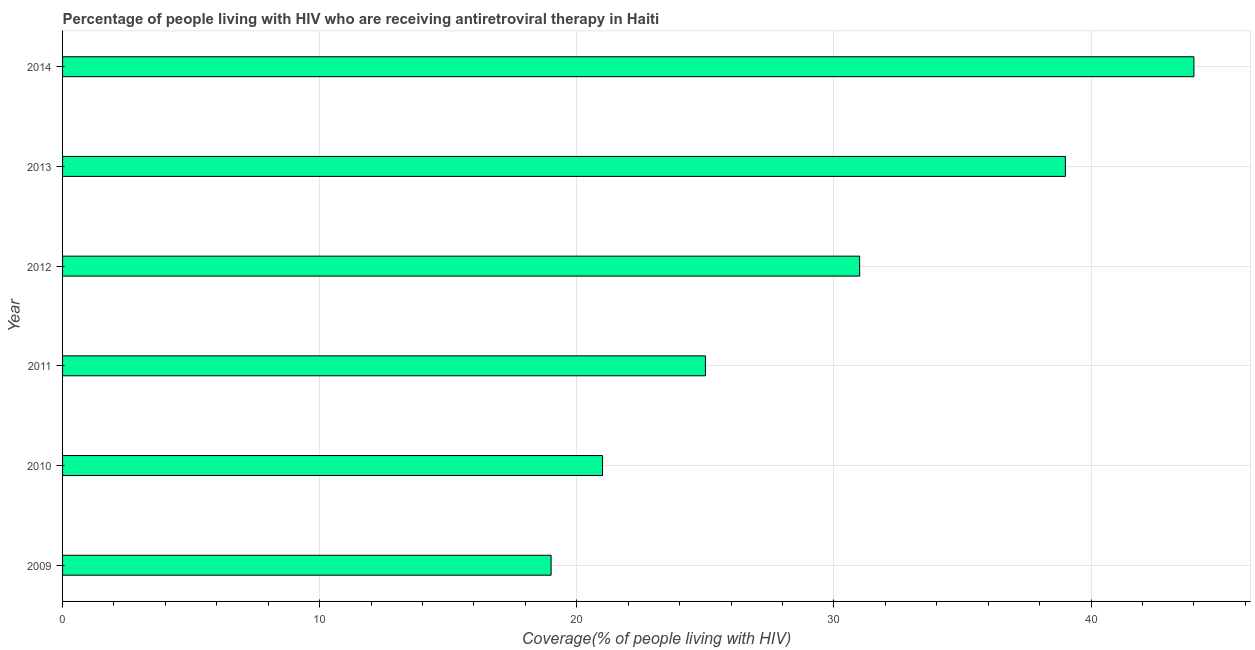What is the title of the graph?
Make the answer very short. Percentage of people living with HIV who are receiving antiretroviral therapy in Haiti. What is the label or title of the X-axis?
Provide a short and direct response. Coverage(% of people living with HIV). What is the label or title of the Y-axis?
Offer a very short reply. Year. Across all years, what is the maximum antiretroviral therapy coverage?
Make the answer very short. 44. Across all years, what is the minimum antiretroviral therapy coverage?
Your response must be concise. 19. In which year was the antiretroviral therapy coverage maximum?
Offer a very short reply. 2014. What is the sum of the antiretroviral therapy coverage?
Give a very brief answer. 179. What is the average antiretroviral therapy coverage per year?
Your answer should be very brief. 29. What is the median antiretroviral therapy coverage?
Your answer should be compact. 28. What is the ratio of the antiretroviral therapy coverage in 2011 to that in 2014?
Provide a short and direct response. 0.57. Is the antiretroviral therapy coverage in 2009 less than that in 2010?
Your response must be concise. Yes. In how many years, is the antiretroviral therapy coverage greater than the average antiretroviral therapy coverage taken over all years?
Make the answer very short. 3. Are all the bars in the graph horizontal?
Ensure brevity in your answer.  Yes. Are the values on the major ticks of X-axis written in scientific E-notation?
Your response must be concise. No. What is the Coverage(% of people living with HIV) of 2010?
Offer a terse response. 21. What is the difference between the Coverage(% of people living with HIV) in 2009 and 2010?
Offer a very short reply. -2. What is the difference between the Coverage(% of people living with HIV) in 2009 and 2011?
Offer a very short reply. -6. What is the difference between the Coverage(% of people living with HIV) in 2009 and 2013?
Provide a short and direct response. -20. What is the difference between the Coverage(% of people living with HIV) in 2010 and 2011?
Give a very brief answer. -4. What is the difference between the Coverage(% of people living with HIV) in 2010 and 2013?
Provide a short and direct response. -18. What is the difference between the Coverage(% of people living with HIV) in 2010 and 2014?
Provide a short and direct response. -23. What is the difference between the Coverage(% of people living with HIV) in 2011 and 2012?
Provide a succinct answer. -6. What is the difference between the Coverage(% of people living with HIV) in 2011 and 2013?
Ensure brevity in your answer.  -14. What is the difference between the Coverage(% of people living with HIV) in 2012 and 2013?
Your answer should be compact. -8. What is the difference between the Coverage(% of people living with HIV) in 2013 and 2014?
Your answer should be very brief. -5. What is the ratio of the Coverage(% of people living with HIV) in 2009 to that in 2010?
Keep it short and to the point. 0.91. What is the ratio of the Coverage(% of people living with HIV) in 2009 to that in 2011?
Provide a short and direct response. 0.76. What is the ratio of the Coverage(% of people living with HIV) in 2009 to that in 2012?
Provide a short and direct response. 0.61. What is the ratio of the Coverage(% of people living with HIV) in 2009 to that in 2013?
Your answer should be very brief. 0.49. What is the ratio of the Coverage(% of people living with HIV) in 2009 to that in 2014?
Ensure brevity in your answer.  0.43. What is the ratio of the Coverage(% of people living with HIV) in 2010 to that in 2011?
Provide a succinct answer. 0.84. What is the ratio of the Coverage(% of people living with HIV) in 2010 to that in 2012?
Provide a succinct answer. 0.68. What is the ratio of the Coverage(% of people living with HIV) in 2010 to that in 2013?
Your answer should be very brief. 0.54. What is the ratio of the Coverage(% of people living with HIV) in 2010 to that in 2014?
Provide a succinct answer. 0.48. What is the ratio of the Coverage(% of people living with HIV) in 2011 to that in 2012?
Ensure brevity in your answer.  0.81. What is the ratio of the Coverage(% of people living with HIV) in 2011 to that in 2013?
Provide a short and direct response. 0.64. What is the ratio of the Coverage(% of people living with HIV) in 2011 to that in 2014?
Your answer should be very brief. 0.57. What is the ratio of the Coverage(% of people living with HIV) in 2012 to that in 2013?
Your answer should be very brief. 0.8. What is the ratio of the Coverage(% of people living with HIV) in 2012 to that in 2014?
Keep it short and to the point. 0.7. What is the ratio of the Coverage(% of people living with HIV) in 2013 to that in 2014?
Your answer should be very brief. 0.89. 